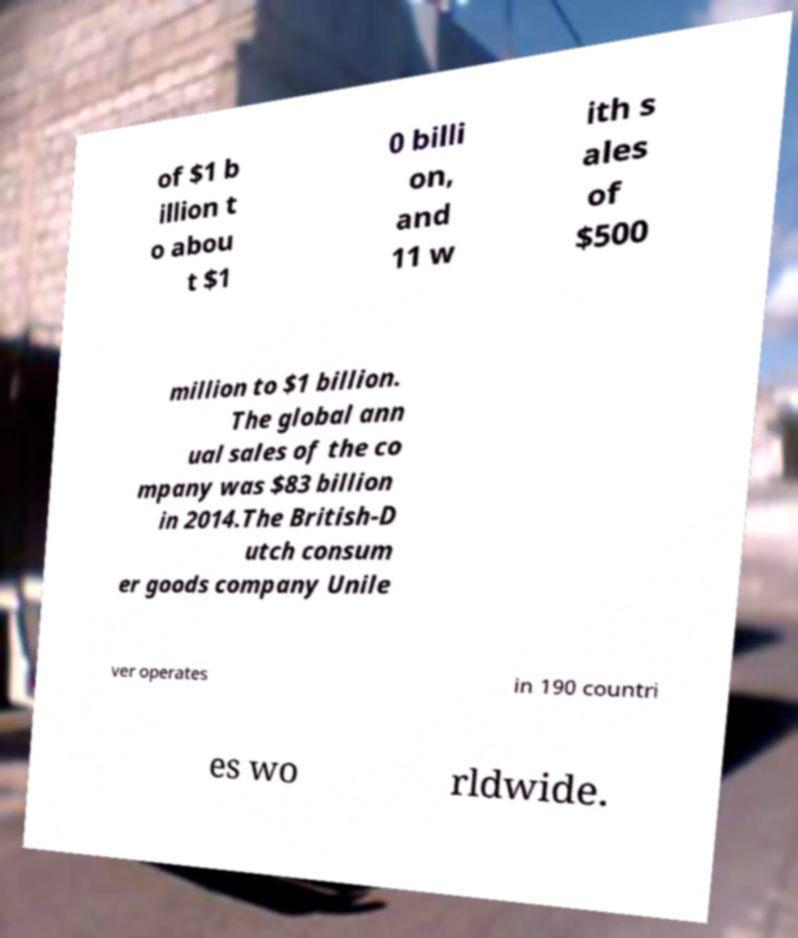Could you extract and type out the text from this image? of $1 b illion t o abou t $1 0 billi on, and 11 w ith s ales of $500 million to $1 billion. The global ann ual sales of the co mpany was $83 billion in 2014.The British-D utch consum er goods company Unile ver operates in 190 countri es wo rldwide. 